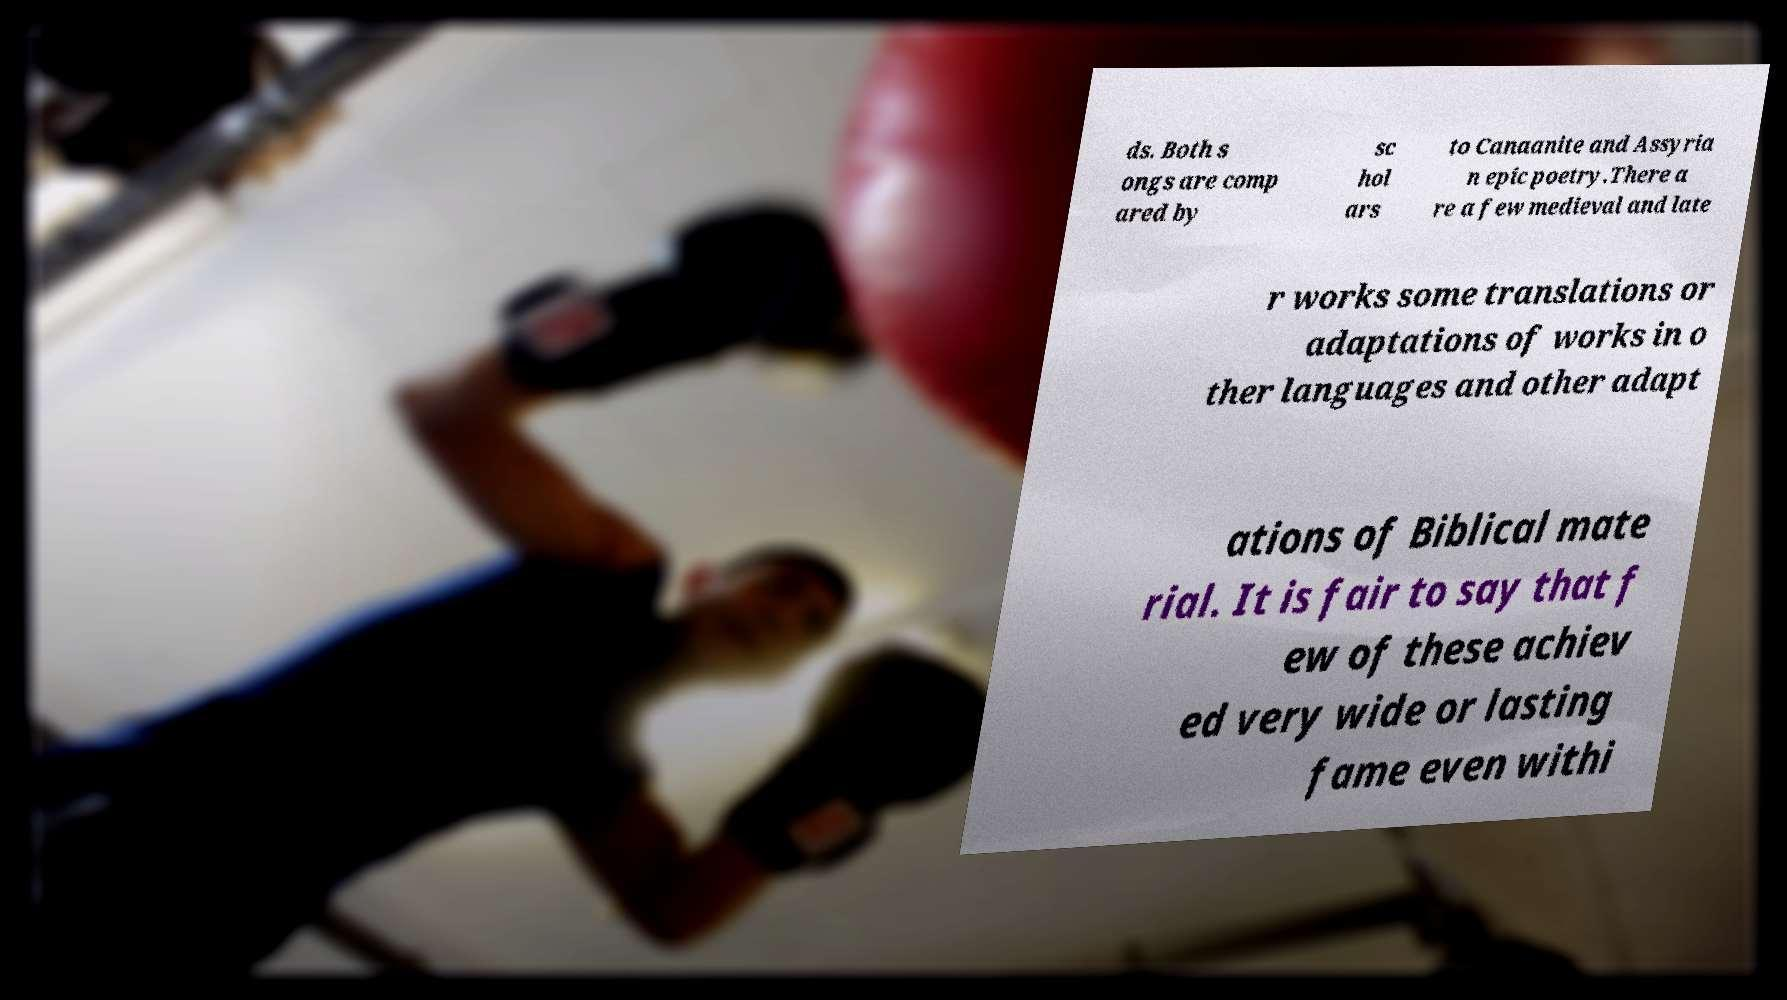There's text embedded in this image that I need extracted. Can you transcribe it verbatim? ds. Both s ongs are comp ared by sc hol ars to Canaanite and Assyria n epic poetry.There a re a few medieval and late r works some translations or adaptations of works in o ther languages and other adapt ations of Biblical mate rial. It is fair to say that f ew of these achiev ed very wide or lasting fame even withi 